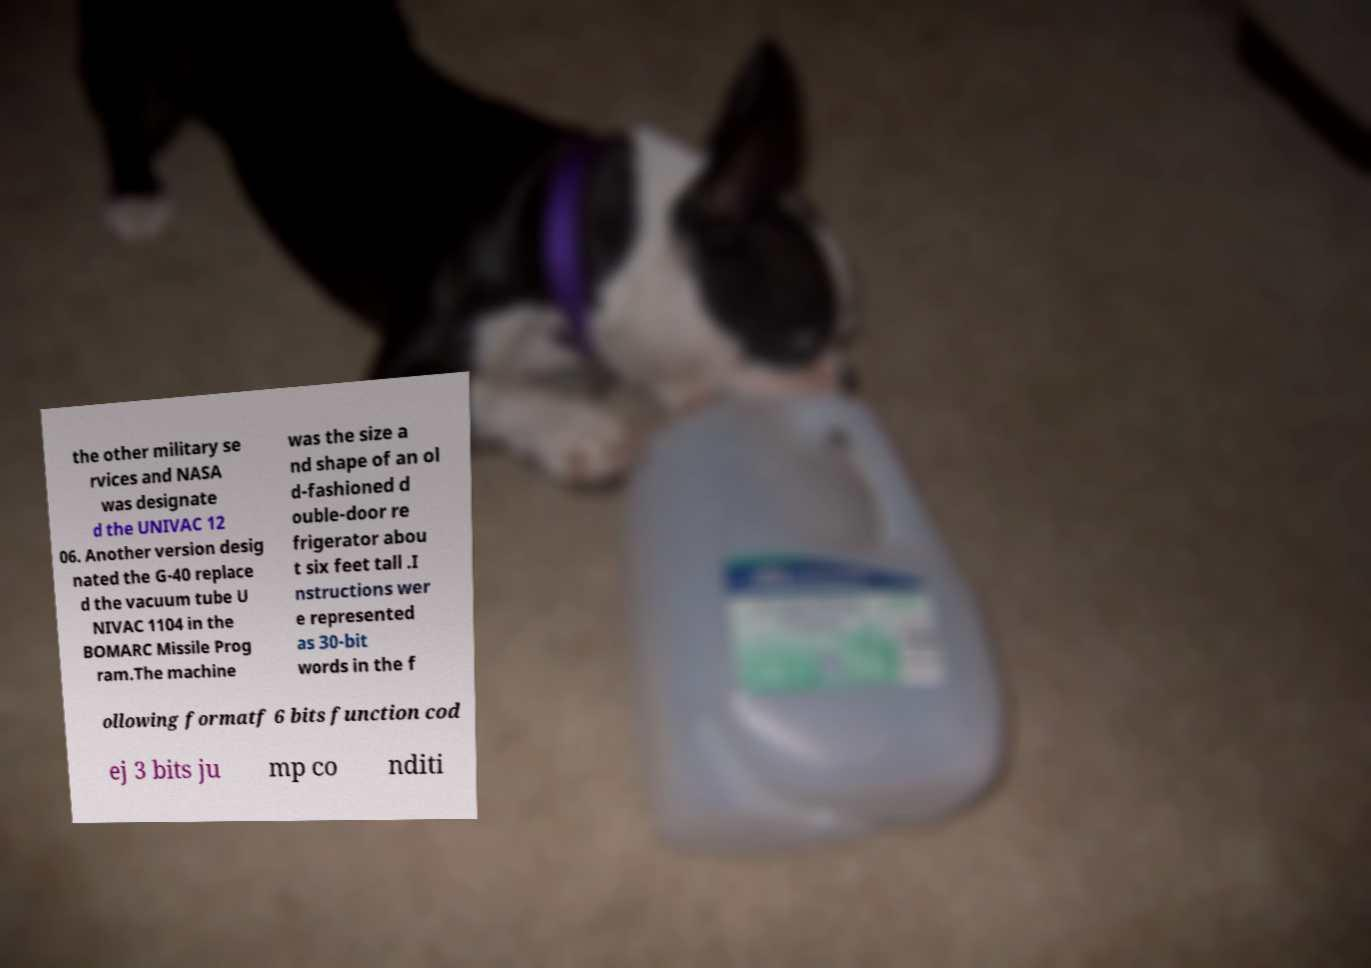There's text embedded in this image that I need extracted. Can you transcribe it verbatim? the other military se rvices and NASA was designate d the UNIVAC 12 06. Another version desig nated the G-40 replace d the vacuum tube U NIVAC 1104 in the BOMARC Missile Prog ram.The machine was the size a nd shape of an ol d-fashioned d ouble-door re frigerator abou t six feet tall .I nstructions wer e represented as 30-bit words in the f ollowing formatf 6 bits function cod ej 3 bits ju mp co nditi 